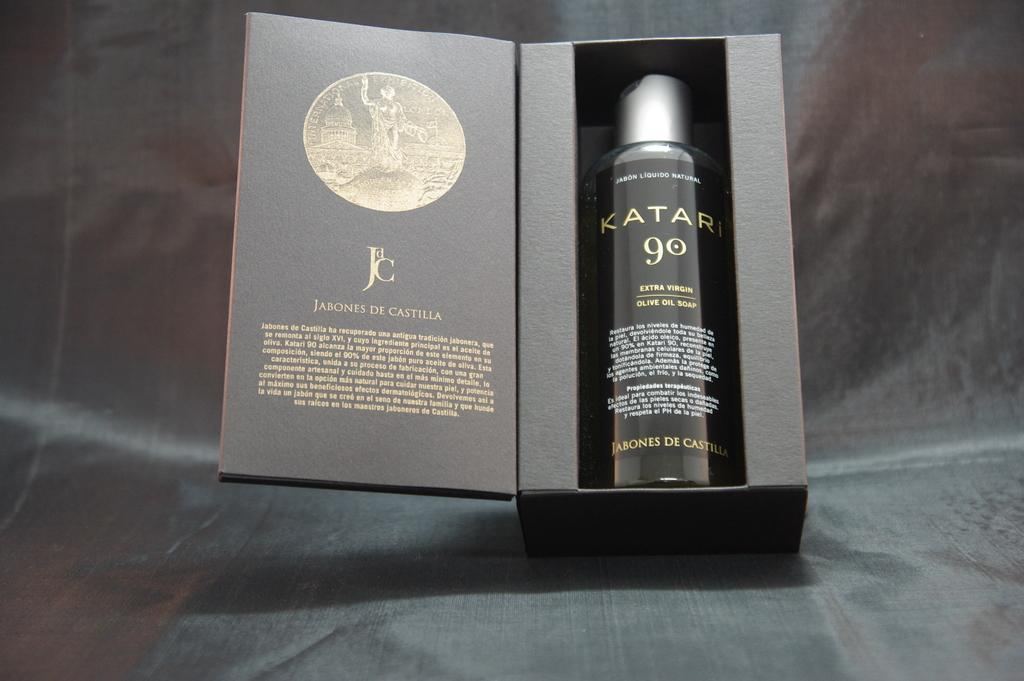<image>
Provide a brief description of the given image. A box that is opened up like a book with a product in it called KATAR 90. 